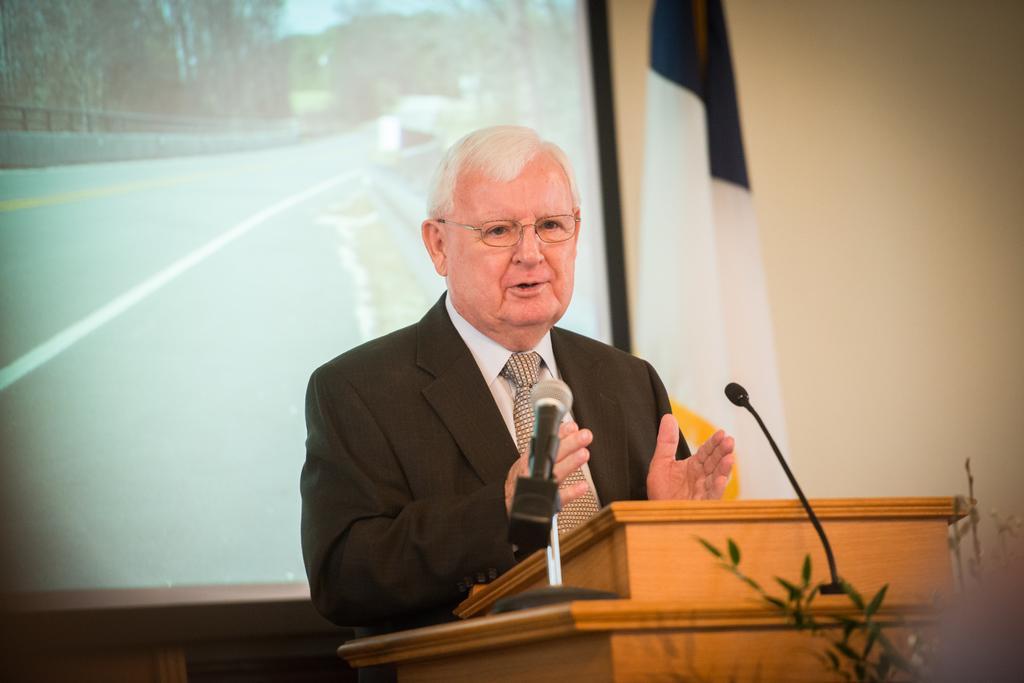How would you summarize this image in a sentence or two? In this image in the center there is one person talking, and in front of him there is a podium and mike. At the bottom there are some plants, and in the background there is a screen, flag and wall. 